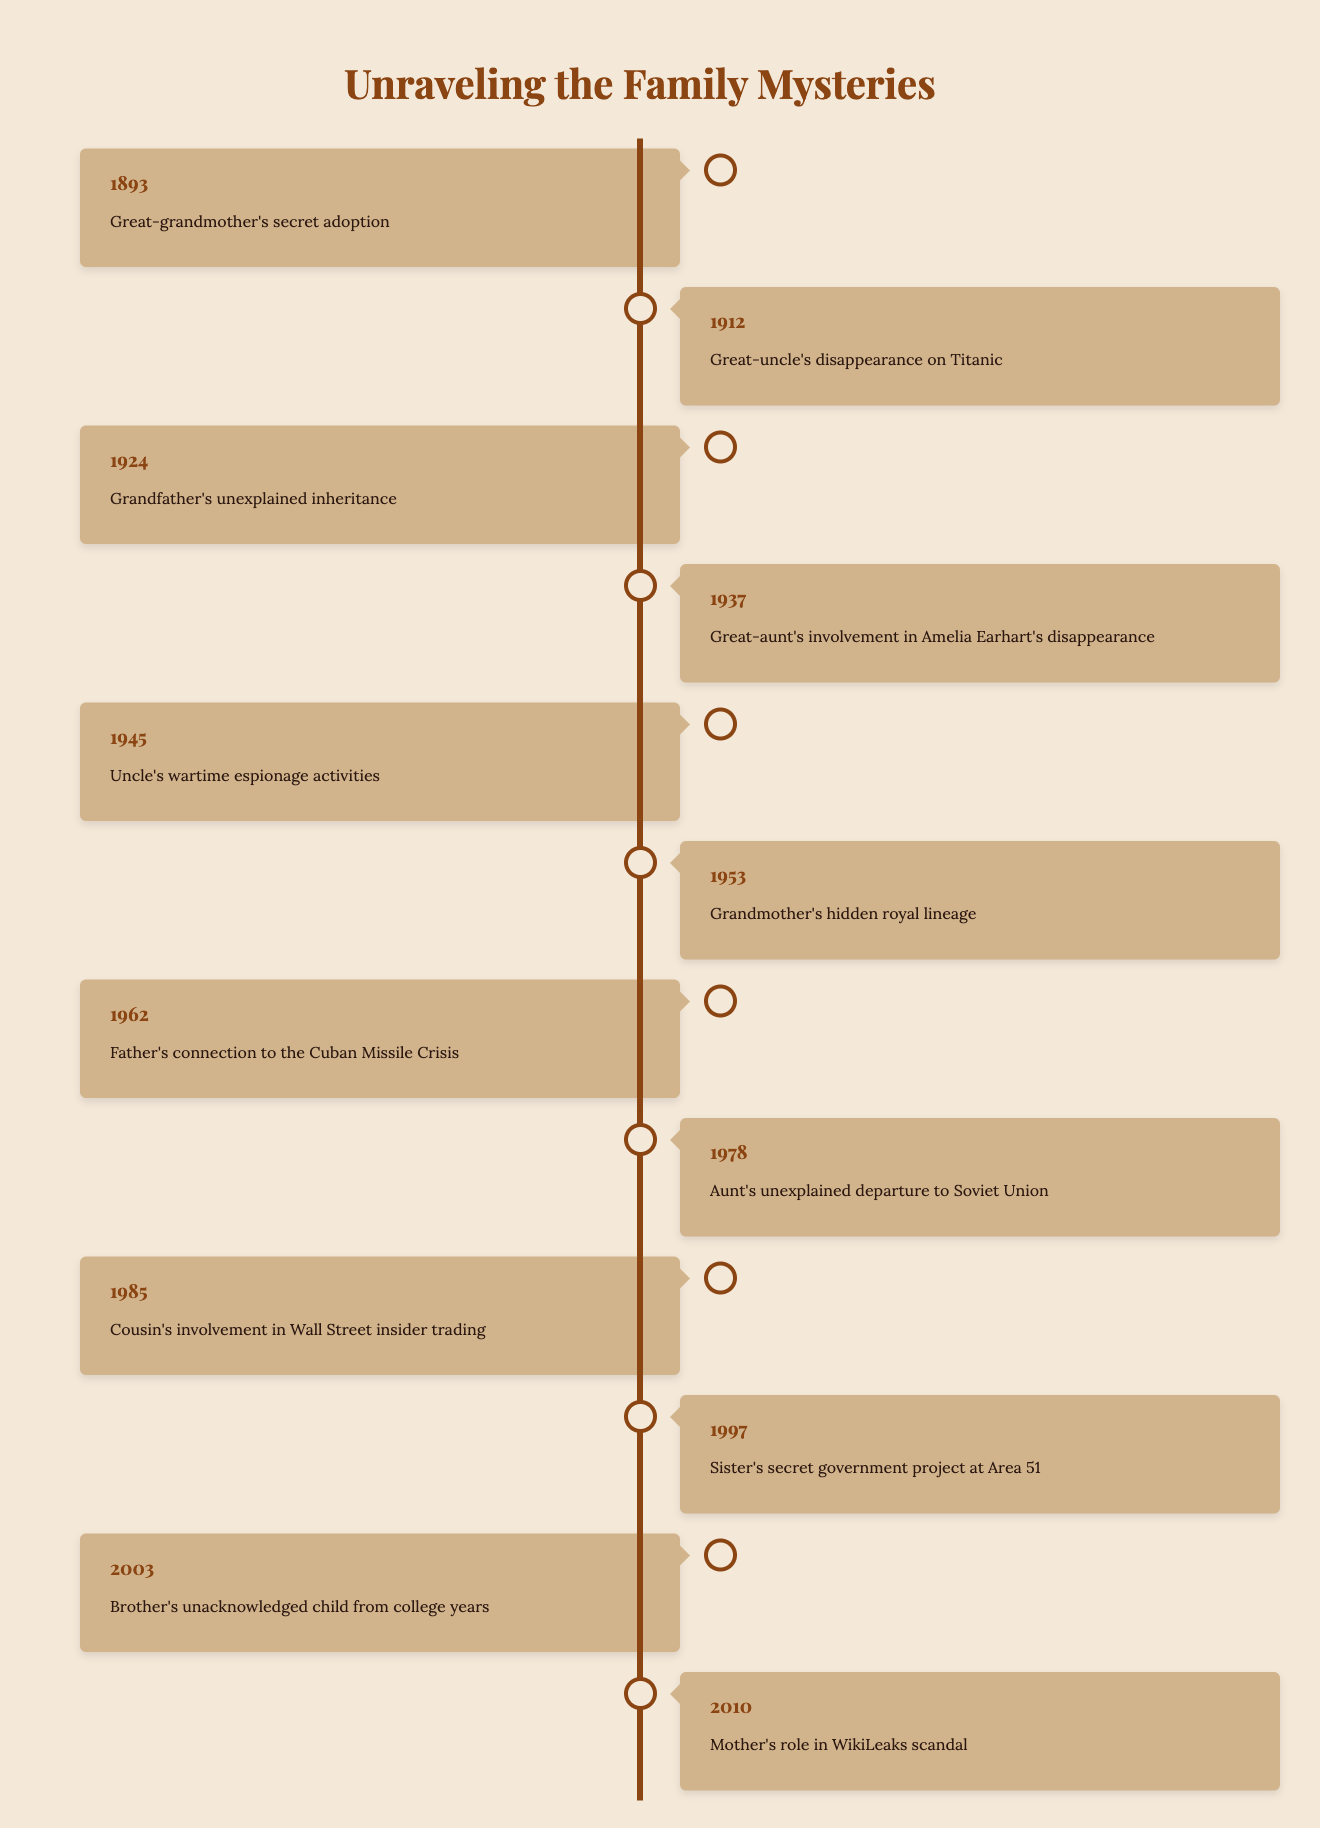What year was the great-aunt involved in the Amelia Earhart disappearance? To find the year associated with the great-aunt's involvement in Amelia Earhart's disappearance, I locate that mystery in the table. The description indicates the event took place in 1937.
Answer: 1937 What is the description of the mystery that involves a secret adoption? The table lists the mystery concerning the secret adoption linked to the great-grandmother in 1893.
Answer: Great-grandmother's secret adoption How many years are represented in the table? By counting the distinct years listed in the table, I find there are 12 unique years mentioned, from 1893 to 2010.
Answer: 12 Which family member was involved in events related to the Cuban Missile Crisis? I look for the relevant description that connects to the Cuban Missile Crisis, which mentions the father in 1962.
Answer: Father What is the earliest mystery related to the family tree? To determine the earliest mystery, I check the years listed in the table and find that the earliest is 1893 concerning the great-grandmother's secret adoption.
Answer: 1893 How many mysteries are related to events that occurred after 1950? I identify the years after 1950 in the table and count the mysteries from 1953 (grandmother's hidden royal lineage) up to 2010; there are 6 mysteries in total.
Answer: 6 Is there any mystery related to insider trading? I look for the specific mention of insider trading in the table and find that the cousin's involvement in Wall Street insider trading is noted in 1985.
Answer: Yes Which year had the most recent family mystery? I assess the years in the table to identify the most recent instance, which is recorded as occurring in 2010 concerning the mother's role in the WikiLeaks scandal.
Answer: 2010 What is the difference in years between the mystery of the unexplained inheritance and the cousin's involvement in insider trading? I find the year for unexplained inheritance, which is 1924, and for insider trading, which is 1985. The difference is calculated as 1985 - 1924 = 61 years.
Answer: 61 Which event occurred closest to the year 2000? Scanning the years around 2000, I see that the year 1997 contains a mystery regarding the sister's secret government project at Area 51, which is three years prior to 2000.
Answer: 1997 